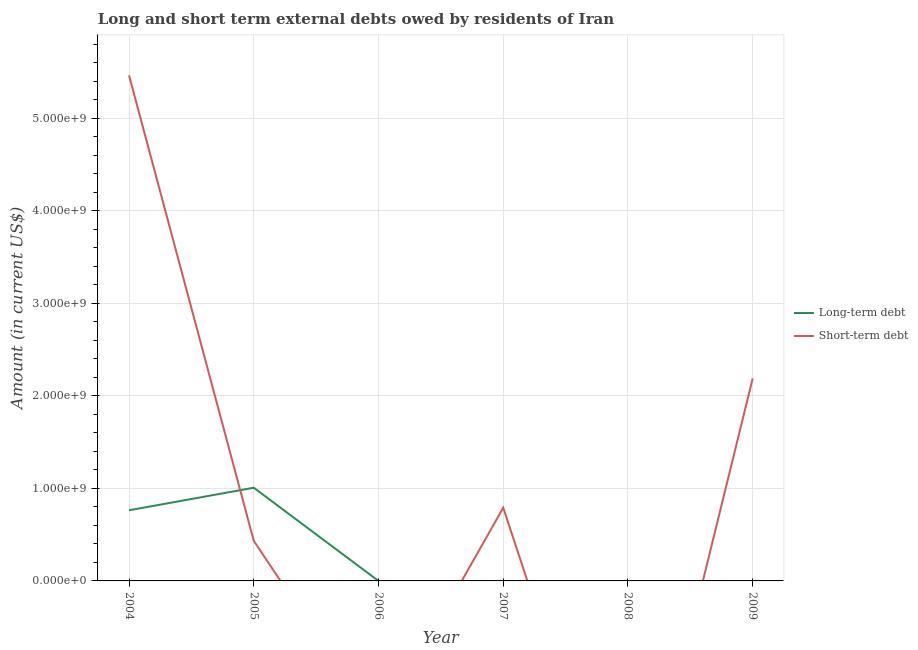What is the short-term debts owed by residents in 2004?
Ensure brevity in your answer.  5.46e+09. Across all years, what is the maximum long-term debts owed by residents?
Your answer should be very brief. 1.01e+09. Across all years, what is the minimum long-term debts owed by residents?
Keep it short and to the point. 0. What is the total long-term debts owed by residents in the graph?
Ensure brevity in your answer.  1.77e+09. What is the difference between the long-term debts owed by residents in 2004 and that in 2005?
Your response must be concise. -2.44e+08. What is the difference between the short-term debts owed by residents in 2005 and the long-term debts owed by residents in 2006?
Ensure brevity in your answer.  4.33e+08. What is the average short-term debts owed by residents per year?
Your answer should be compact. 1.48e+09. In the year 2005, what is the difference between the short-term debts owed by residents and long-term debts owed by residents?
Give a very brief answer. -5.74e+08. In how many years, is the short-term debts owed by residents greater than 4800000000 US$?
Your answer should be compact. 1. What is the ratio of the short-term debts owed by residents in 2004 to that in 2009?
Provide a short and direct response. 2.5. Is the short-term debts owed by residents in 2004 less than that in 2007?
Provide a short and direct response. No. What is the difference between the highest and the second highest short-term debts owed by residents?
Offer a terse response. 3.27e+09. What is the difference between the highest and the lowest short-term debts owed by residents?
Offer a very short reply. 5.46e+09. In how many years, is the long-term debts owed by residents greater than the average long-term debts owed by residents taken over all years?
Your answer should be compact. 2. Is the sum of the short-term debts owed by residents in 2004 and 2005 greater than the maximum long-term debts owed by residents across all years?
Your answer should be very brief. Yes. Does the short-term debts owed by residents monotonically increase over the years?
Your answer should be very brief. No. Is the short-term debts owed by residents strictly greater than the long-term debts owed by residents over the years?
Keep it short and to the point. No. How many lines are there?
Offer a very short reply. 2. Are the values on the major ticks of Y-axis written in scientific E-notation?
Provide a succinct answer. Yes. Does the graph contain any zero values?
Provide a short and direct response. Yes. What is the title of the graph?
Offer a very short reply. Long and short term external debts owed by residents of Iran. What is the label or title of the X-axis?
Give a very brief answer. Year. What is the Amount (in current US$) of Long-term debt in 2004?
Ensure brevity in your answer.  7.63e+08. What is the Amount (in current US$) in Short-term debt in 2004?
Provide a short and direct response. 5.46e+09. What is the Amount (in current US$) of Long-term debt in 2005?
Your answer should be compact. 1.01e+09. What is the Amount (in current US$) of Short-term debt in 2005?
Ensure brevity in your answer.  4.33e+08. What is the Amount (in current US$) in Long-term debt in 2006?
Offer a very short reply. 0. What is the Amount (in current US$) in Short-term debt in 2006?
Your answer should be very brief. 0. What is the Amount (in current US$) in Long-term debt in 2007?
Provide a succinct answer. 0. What is the Amount (in current US$) in Short-term debt in 2007?
Provide a succinct answer. 7.91e+08. What is the Amount (in current US$) in Short-term debt in 2008?
Your answer should be very brief. 0. What is the Amount (in current US$) of Long-term debt in 2009?
Your response must be concise. 0. What is the Amount (in current US$) in Short-term debt in 2009?
Ensure brevity in your answer.  2.19e+09. Across all years, what is the maximum Amount (in current US$) of Long-term debt?
Offer a very short reply. 1.01e+09. Across all years, what is the maximum Amount (in current US$) of Short-term debt?
Give a very brief answer. 5.46e+09. Across all years, what is the minimum Amount (in current US$) in Long-term debt?
Offer a very short reply. 0. What is the total Amount (in current US$) in Long-term debt in the graph?
Keep it short and to the point. 1.77e+09. What is the total Amount (in current US$) of Short-term debt in the graph?
Offer a terse response. 8.87e+09. What is the difference between the Amount (in current US$) of Long-term debt in 2004 and that in 2005?
Offer a terse response. -2.44e+08. What is the difference between the Amount (in current US$) in Short-term debt in 2004 and that in 2005?
Offer a terse response. 5.03e+09. What is the difference between the Amount (in current US$) of Short-term debt in 2004 and that in 2007?
Keep it short and to the point. 4.67e+09. What is the difference between the Amount (in current US$) in Short-term debt in 2004 and that in 2009?
Offer a terse response. 3.27e+09. What is the difference between the Amount (in current US$) of Short-term debt in 2005 and that in 2007?
Your answer should be compact. -3.58e+08. What is the difference between the Amount (in current US$) in Short-term debt in 2005 and that in 2009?
Provide a succinct answer. -1.76e+09. What is the difference between the Amount (in current US$) in Short-term debt in 2007 and that in 2009?
Ensure brevity in your answer.  -1.40e+09. What is the difference between the Amount (in current US$) of Long-term debt in 2004 and the Amount (in current US$) of Short-term debt in 2005?
Make the answer very short. 3.30e+08. What is the difference between the Amount (in current US$) in Long-term debt in 2004 and the Amount (in current US$) in Short-term debt in 2007?
Give a very brief answer. -2.77e+07. What is the difference between the Amount (in current US$) in Long-term debt in 2004 and the Amount (in current US$) in Short-term debt in 2009?
Ensure brevity in your answer.  -1.42e+09. What is the difference between the Amount (in current US$) in Long-term debt in 2005 and the Amount (in current US$) in Short-term debt in 2007?
Provide a short and direct response. 2.16e+08. What is the difference between the Amount (in current US$) of Long-term debt in 2005 and the Amount (in current US$) of Short-term debt in 2009?
Your answer should be compact. -1.18e+09. What is the average Amount (in current US$) in Long-term debt per year?
Provide a succinct answer. 2.95e+08. What is the average Amount (in current US$) in Short-term debt per year?
Your answer should be very brief. 1.48e+09. In the year 2004, what is the difference between the Amount (in current US$) of Long-term debt and Amount (in current US$) of Short-term debt?
Offer a terse response. -4.70e+09. In the year 2005, what is the difference between the Amount (in current US$) in Long-term debt and Amount (in current US$) in Short-term debt?
Your answer should be very brief. 5.74e+08. What is the ratio of the Amount (in current US$) of Long-term debt in 2004 to that in 2005?
Offer a very short reply. 0.76. What is the ratio of the Amount (in current US$) of Short-term debt in 2004 to that in 2005?
Make the answer very short. 12.61. What is the ratio of the Amount (in current US$) in Short-term debt in 2004 to that in 2007?
Give a very brief answer. 6.91. What is the ratio of the Amount (in current US$) of Short-term debt in 2004 to that in 2009?
Provide a succinct answer. 2.5. What is the ratio of the Amount (in current US$) in Short-term debt in 2005 to that in 2007?
Provide a succinct answer. 0.55. What is the ratio of the Amount (in current US$) of Short-term debt in 2005 to that in 2009?
Provide a short and direct response. 0.2. What is the ratio of the Amount (in current US$) in Short-term debt in 2007 to that in 2009?
Offer a very short reply. 0.36. What is the difference between the highest and the second highest Amount (in current US$) in Short-term debt?
Make the answer very short. 3.27e+09. What is the difference between the highest and the lowest Amount (in current US$) in Long-term debt?
Keep it short and to the point. 1.01e+09. What is the difference between the highest and the lowest Amount (in current US$) in Short-term debt?
Offer a terse response. 5.46e+09. 